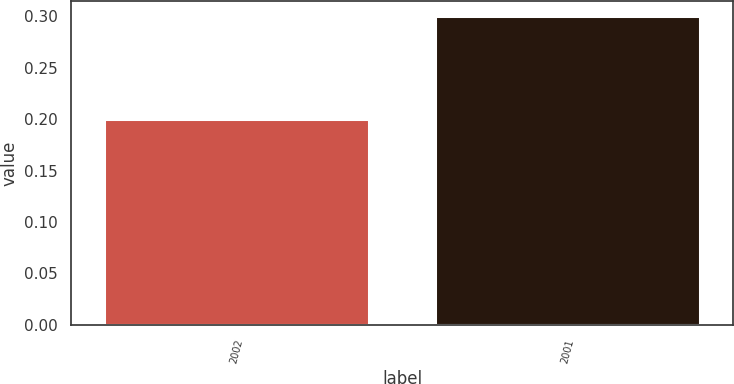Convert chart to OTSL. <chart><loc_0><loc_0><loc_500><loc_500><bar_chart><fcel>2002<fcel>2001<nl><fcel>0.2<fcel>0.3<nl></chart> 